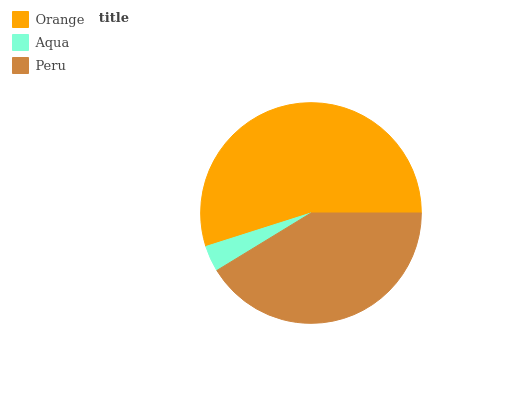Is Aqua the minimum?
Answer yes or no. Yes. Is Orange the maximum?
Answer yes or no. Yes. Is Peru the minimum?
Answer yes or no. No. Is Peru the maximum?
Answer yes or no. No. Is Peru greater than Aqua?
Answer yes or no. Yes. Is Aqua less than Peru?
Answer yes or no. Yes. Is Aqua greater than Peru?
Answer yes or no. No. Is Peru less than Aqua?
Answer yes or no. No. Is Peru the high median?
Answer yes or no. Yes. Is Peru the low median?
Answer yes or no. Yes. Is Orange the high median?
Answer yes or no. No. Is Orange the low median?
Answer yes or no. No. 